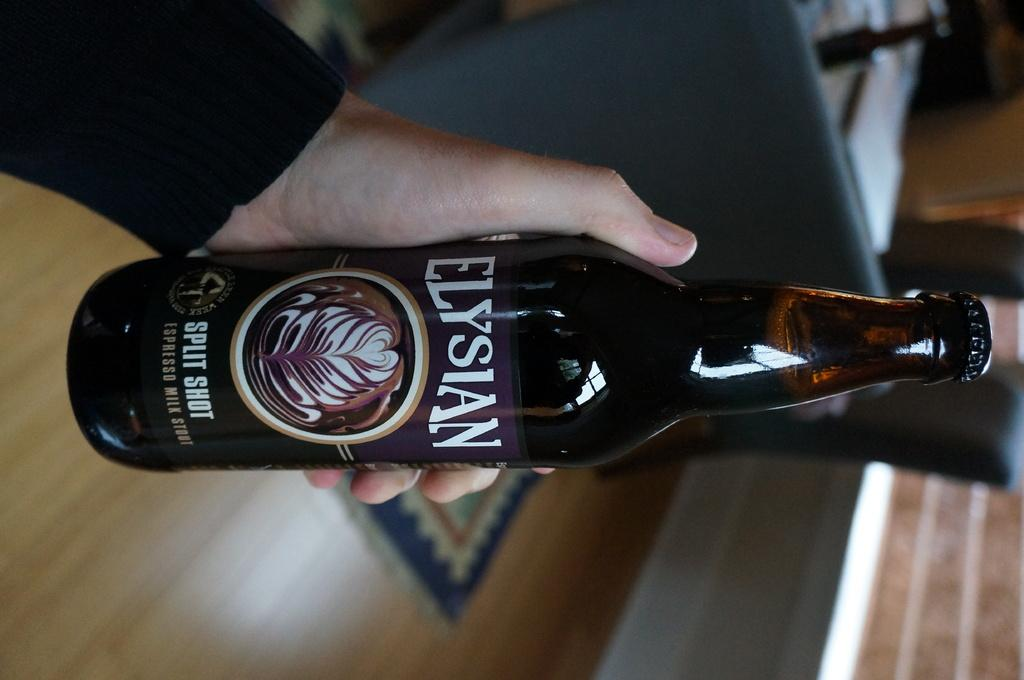What is the main subject of the image? There is a person in the image. What is the person holding in the image? The person is holding a bottle. What can be seen beneath the person in the image? The floor is visible in the image. How many airplanes are visible in the image? There are no airplanes present in the image. Are there any ants crawling on the person in the image? There is no indication of ants in the image. 